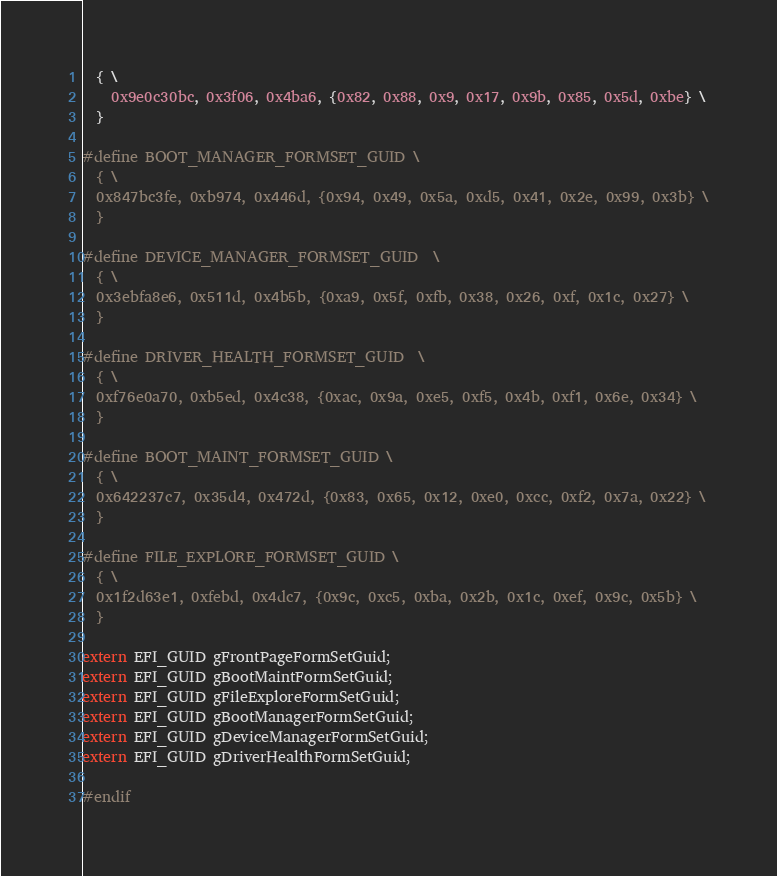Convert code to text. <code><loc_0><loc_0><loc_500><loc_500><_C_>  { \
    0x9e0c30bc, 0x3f06, 0x4ba6, {0x82, 0x88, 0x9, 0x17, 0x9b, 0x85, 0x5d, 0xbe} \
  }

#define BOOT_MANAGER_FORMSET_GUID \
  { \
  0x847bc3fe, 0xb974, 0x446d, {0x94, 0x49, 0x5a, 0xd5, 0x41, 0x2e, 0x99, 0x3b} \
  }

#define DEVICE_MANAGER_FORMSET_GUID  \
  { \
  0x3ebfa8e6, 0x511d, 0x4b5b, {0xa9, 0x5f, 0xfb, 0x38, 0x26, 0xf, 0x1c, 0x27} \
  }

#define DRIVER_HEALTH_FORMSET_GUID  \
  { \
  0xf76e0a70, 0xb5ed, 0x4c38, {0xac, 0x9a, 0xe5, 0xf5, 0x4b, 0xf1, 0x6e, 0x34} \
  }

#define BOOT_MAINT_FORMSET_GUID \
  { \
  0x642237c7, 0x35d4, 0x472d, {0x83, 0x65, 0x12, 0xe0, 0xcc, 0xf2, 0x7a, 0x22} \
  }

#define FILE_EXPLORE_FORMSET_GUID \
  { \
  0x1f2d63e1, 0xfebd, 0x4dc7, {0x9c, 0xc5, 0xba, 0x2b, 0x1c, 0xef, 0x9c, 0x5b} \
  }

extern EFI_GUID gFrontPageFormSetGuid;
extern EFI_GUID gBootMaintFormSetGuid;
extern EFI_GUID gFileExploreFormSetGuid;
extern EFI_GUID gBootManagerFormSetGuid;
extern EFI_GUID gDeviceManagerFormSetGuid;
extern EFI_GUID gDriverHealthFormSetGuid;

#endif
</code> 